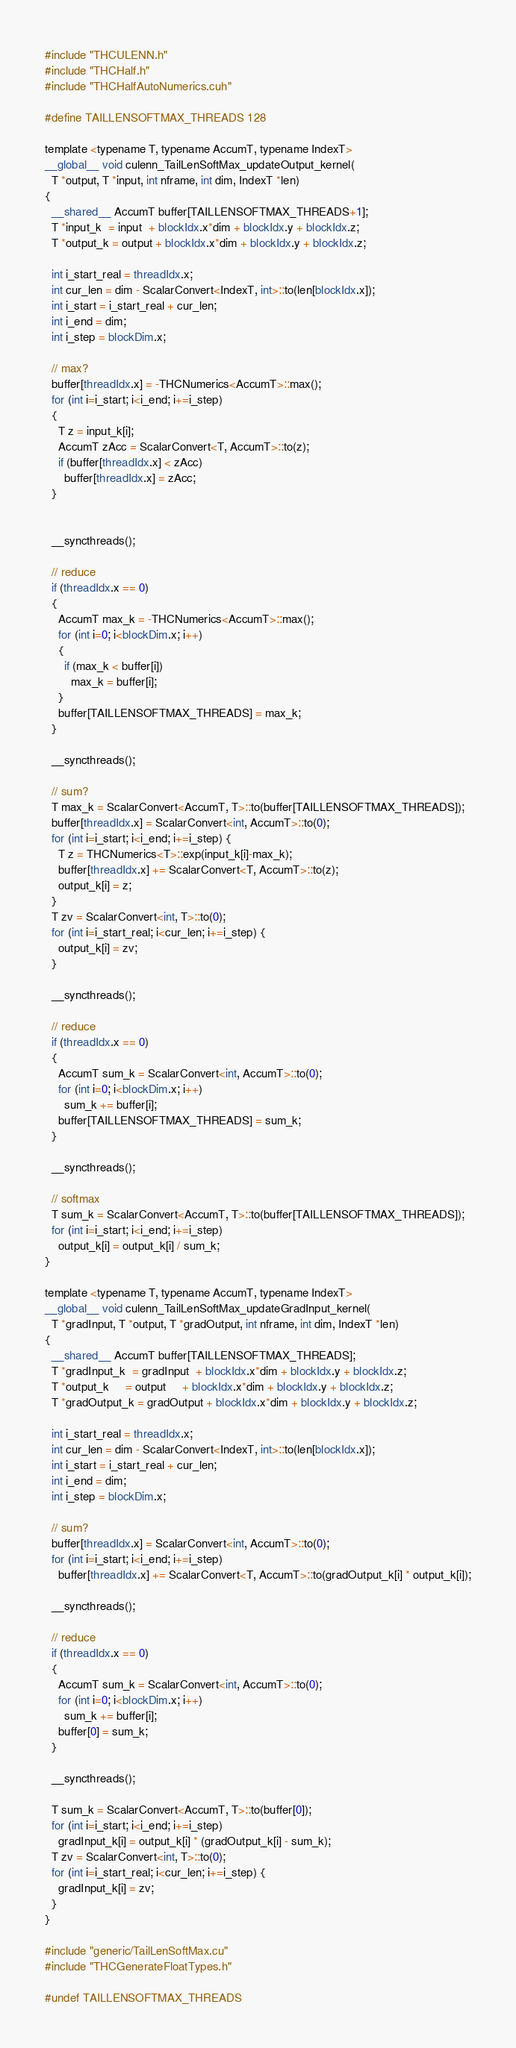<code> <loc_0><loc_0><loc_500><loc_500><_Cuda_>#include "THCULENN.h"
#include "THCHalf.h"
#include "THCHalfAutoNumerics.cuh"

#define TAILLENSOFTMAX_THREADS 128

template <typename T, typename AccumT, typename IndexT>
__global__ void culenn_TailLenSoftMax_updateOutput_kernel(
  T *output, T *input, int nframe, int dim, IndexT *len)
{
  __shared__ AccumT buffer[TAILLENSOFTMAX_THREADS+1];
  T *input_k  = input  + blockIdx.x*dim + blockIdx.y + blockIdx.z;
  T *output_k = output + blockIdx.x*dim + blockIdx.y + blockIdx.z;

  int i_start_real = threadIdx.x;
  int cur_len = dim - ScalarConvert<IndexT, int>::to(len[blockIdx.x]);
  int i_start = i_start_real + cur_len;
  int i_end = dim;
  int i_step = blockDim.x;

  // max?
  buffer[threadIdx.x] = -THCNumerics<AccumT>::max();
  for (int i=i_start; i<i_end; i+=i_step)
  {
    T z = input_k[i];
    AccumT zAcc = ScalarConvert<T, AccumT>::to(z);
    if (buffer[threadIdx.x] < zAcc)
      buffer[threadIdx.x] = zAcc;
  }


  __syncthreads();

  // reduce
  if (threadIdx.x == 0)
  {
    AccumT max_k = -THCNumerics<AccumT>::max();
    for (int i=0; i<blockDim.x; i++)
    {
      if (max_k < buffer[i])
        max_k = buffer[i];
    }
    buffer[TAILLENSOFTMAX_THREADS] = max_k;
  }

  __syncthreads();

  // sum?
  T max_k = ScalarConvert<AccumT, T>::to(buffer[TAILLENSOFTMAX_THREADS]);
  buffer[threadIdx.x] = ScalarConvert<int, AccumT>::to(0);
  for (int i=i_start; i<i_end; i+=i_step) {
    T z = THCNumerics<T>::exp(input_k[i]-max_k);
    buffer[threadIdx.x] += ScalarConvert<T, AccumT>::to(z);
    output_k[i] = z;
  }
  T zv = ScalarConvert<int, T>::to(0);
  for (int i=i_start_real; i<cur_len; i+=i_step) {
    output_k[i] = zv;
  }

  __syncthreads();

  // reduce
  if (threadIdx.x == 0)
  {
    AccumT sum_k = ScalarConvert<int, AccumT>::to(0);
    for (int i=0; i<blockDim.x; i++)
      sum_k += buffer[i];
    buffer[TAILLENSOFTMAX_THREADS] = sum_k;
  }

  __syncthreads();

  // softmax
  T sum_k = ScalarConvert<AccumT, T>::to(buffer[TAILLENSOFTMAX_THREADS]);
  for (int i=i_start; i<i_end; i+=i_step)
    output_k[i] = output_k[i] / sum_k;
}

template <typename T, typename AccumT, typename IndexT>
__global__ void culenn_TailLenSoftMax_updateGradInput_kernel(
  T *gradInput, T *output, T *gradOutput, int nframe, int dim, IndexT *len)
{
  __shared__ AccumT buffer[TAILLENSOFTMAX_THREADS];
  T *gradInput_k  = gradInput  + blockIdx.x*dim + blockIdx.y + blockIdx.z;
  T *output_k     = output     + blockIdx.x*dim + blockIdx.y + blockIdx.z;
  T *gradOutput_k = gradOutput + blockIdx.x*dim + blockIdx.y + blockIdx.z;

  int i_start_real = threadIdx.x;
  int cur_len = dim - ScalarConvert<IndexT, int>::to(len[blockIdx.x]);
  int i_start = i_start_real + cur_len;
  int i_end = dim;
  int i_step = blockDim.x;

  // sum?
  buffer[threadIdx.x] = ScalarConvert<int, AccumT>::to(0);
  for (int i=i_start; i<i_end; i+=i_step)
    buffer[threadIdx.x] += ScalarConvert<T, AccumT>::to(gradOutput_k[i] * output_k[i]);

  __syncthreads();

  // reduce
  if (threadIdx.x == 0)
  {
    AccumT sum_k = ScalarConvert<int, AccumT>::to(0);
    for (int i=0; i<blockDim.x; i++)
      sum_k += buffer[i];
    buffer[0] = sum_k;
  }

  __syncthreads();

  T sum_k = ScalarConvert<AccumT, T>::to(buffer[0]);
  for (int i=i_start; i<i_end; i+=i_step)
    gradInput_k[i] = output_k[i] * (gradOutput_k[i] - sum_k);
  T zv = ScalarConvert<int, T>::to(0);
  for (int i=i_start_real; i<cur_len; i+=i_step) {
    gradInput_k[i] = zv;
  }
}

#include "generic/TailLenSoftMax.cu"
#include "THCGenerateFloatTypes.h"

#undef TAILLENSOFTMAX_THREADS
</code> 